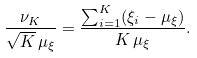<formula> <loc_0><loc_0><loc_500><loc_500>\frac { \nu _ { K } } { \sqrt { K } \, \mu _ { \xi } } = \frac { \sum _ { i = 1 } ^ { K } ( \xi _ { i } - \mu _ { \xi } ) } { K \, \mu _ { \xi } } .</formula> 